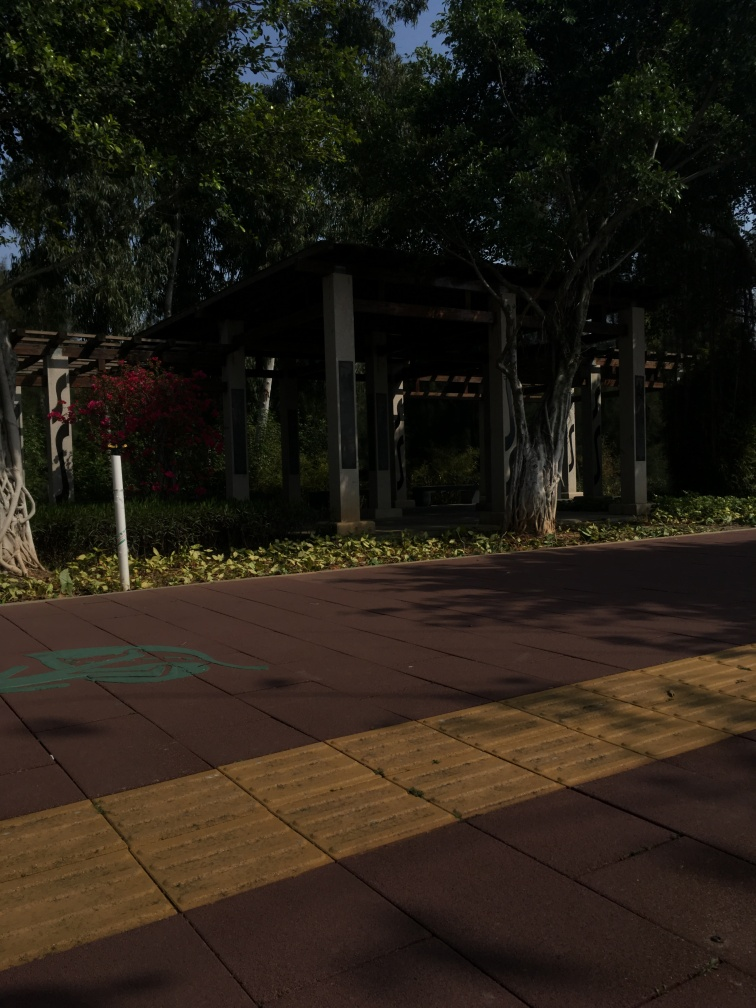What time of the day do you think it is, based on the image? Considering the length and position of the shadows projected by the trees and structures, I would infer that the photo was taken in the late afternoon. This is typically when the sun is lower on the horizon, resulting in longer shadows extending eastward, as they appear to do in the image. 